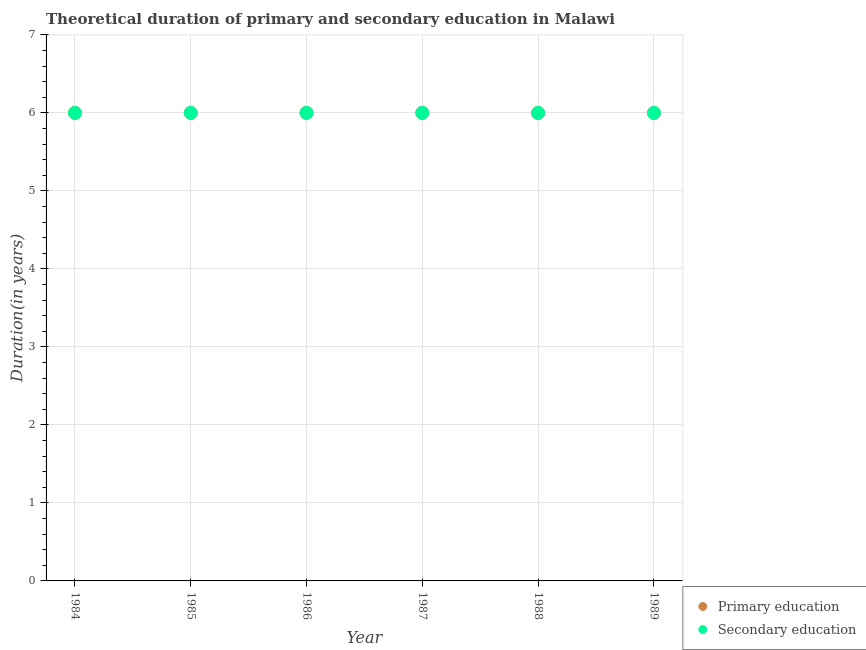Is the number of dotlines equal to the number of legend labels?
Offer a terse response. Yes. Across all years, what is the minimum duration of primary education?
Your answer should be compact. 6. In which year was the duration of primary education maximum?
Give a very brief answer. 1984. What is the total duration of primary education in the graph?
Offer a very short reply. 36. What is the difference between the duration of primary education in 1984 and that in 1988?
Ensure brevity in your answer.  0. What is the difference between the duration of primary education in 1989 and the duration of secondary education in 1988?
Give a very brief answer. 0. In the year 1988, what is the difference between the duration of secondary education and duration of primary education?
Give a very brief answer. 0. In how many years, is the duration of secondary education greater than 5.2 years?
Offer a very short reply. 6. Is the duration of secondary education in 1986 less than that in 1989?
Offer a very short reply. No. What is the difference between the highest and the second highest duration of secondary education?
Offer a very short reply. 0. In how many years, is the duration of primary education greater than the average duration of primary education taken over all years?
Your response must be concise. 0. Is the duration of primary education strictly greater than the duration of secondary education over the years?
Your answer should be compact. No. How many dotlines are there?
Keep it short and to the point. 2. How many years are there in the graph?
Keep it short and to the point. 6. What is the difference between two consecutive major ticks on the Y-axis?
Your answer should be very brief. 1. Where does the legend appear in the graph?
Offer a terse response. Bottom right. How many legend labels are there?
Give a very brief answer. 2. What is the title of the graph?
Give a very brief answer. Theoretical duration of primary and secondary education in Malawi. Does "Central government" appear as one of the legend labels in the graph?
Provide a succinct answer. No. What is the label or title of the Y-axis?
Ensure brevity in your answer.  Duration(in years). What is the Duration(in years) of Primary education in 1984?
Your answer should be very brief. 6. What is the Duration(in years) in Secondary education in 1984?
Your response must be concise. 6. What is the Duration(in years) in Primary education in 1989?
Your answer should be very brief. 6. Across all years, what is the maximum Duration(in years) of Primary education?
Provide a succinct answer. 6. Across all years, what is the minimum Duration(in years) in Primary education?
Give a very brief answer. 6. Across all years, what is the minimum Duration(in years) in Secondary education?
Your answer should be compact. 6. What is the total Duration(in years) in Primary education in the graph?
Your answer should be very brief. 36. What is the difference between the Duration(in years) of Primary education in 1984 and that in 1986?
Keep it short and to the point. 0. What is the difference between the Duration(in years) in Secondary education in 1984 and that in 1987?
Your answer should be compact. 0. What is the difference between the Duration(in years) in Primary education in 1984 and that in 1988?
Your response must be concise. 0. What is the difference between the Duration(in years) of Secondary education in 1984 and that in 1988?
Keep it short and to the point. 0. What is the difference between the Duration(in years) in Secondary education in 1984 and that in 1989?
Your answer should be compact. 0. What is the difference between the Duration(in years) of Secondary education in 1985 and that in 1986?
Provide a succinct answer. 0. What is the difference between the Duration(in years) in Primary education in 1985 and that in 1987?
Your response must be concise. 0. What is the difference between the Duration(in years) of Secondary education in 1985 and that in 1987?
Your answer should be very brief. 0. What is the difference between the Duration(in years) of Primary education in 1985 and that in 1988?
Provide a succinct answer. 0. What is the difference between the Duration(in years) of Secondary education in 1985 and that in 1988?
Offer a very short reply. 0. What is the difference between the Duration(in years) in Secondary education in 1985 and that in 1989?
Provide a succinct answer. 0. What is the difference between the Duration(in years) of Secondary education in 1986 and that in 1988?
Provide a short and direct response. 0. What is the difference between the Duration(in years) in Primary education in 1986 and that in 1989?
Offer a very short reply. 0. What is the difference between the Duration(in years) in Secondary education in 1986 and that in 1989?
Ensure brevity in your answer.  0. What is the difference between the Duration(in years) of Primary education in 1987 and that in 1988?
Give a very brief answer. 0. What is the difference between the Duration(in years) of Primary education in 1987 and that in 1989?
Offer a terse response. 0. What is the difference between the Duration(in years) of Secondary education in 1988 and that in 1989?
Provide a succinct answer. 0. What is the difference between the Duration(in years) in Primary education in 1984 and the Duration(in years) in Secondary education in 1985?
Keep it short and to the point. 0. What is the difference between the Duration(in years) of Primary education in 1984 and the Duration(in years) of Secondary education in 1986?
Offer a terse response. 0. What is the difference between the Duration(in years) of Primary education in 1984 and the Duration(in years) of Secondary education in 1988?
Make the answer very short. 0. What is the difference between the Duration(in years) of Primary education in 1985 and the Duration(in years) of Secondary education in 1988?
Keep it short and to the point. 0. What is the difference between the Duration(in years) of Primary education in 1985 and the Duration(in years) of Secondary education in 1989?
Your answer should be very brief. 0. What is the difference between the Duration(in years) of Primary education in 1987 and the Duration(in years) of Secondary education in 1989?
Keep it short and to the point. 0. What is the difference between the Duration(in years) in Primary education in 1988 and the Duration(in years) in Secondary education in 1989?
Offer a very short reply. 0. What is the average Duration(in years) of Secondary education per year?
Provide a short and direct response. 6. In the year 1984, what is the difference between the Duration(in years) in Primary education and Duration(in years) in Secondary education?
Make the answer very short. 0. In the year 1985, what is the difference between the Duration(in years) in Primary education and Duration(in years) in Secondary education?
Provide a succinct answer. 0. In the year 1987, what is the difference between the Duration(in years) of Primary education and Duration(in years) of Secondary education?
Offer a very short reply. 0. In the year 1989, what is the difference between the Duration(in years) in Primary education and Duration(in years) in Secondary education?
Offer a terse response. 0. What is the ratio of the Duration(in years) in Secondary education in 1984 to that in 1985?
Provide a short and direct response. 1. What is the ratio of the Duration(in years) in Primary education in 1984 to that in 1987?
Give a very brief answer. 1. What is the ratio of the Duration(in years) in Secondary education in 1984 to that in 1987?
Provide a short and direct response. 1. What is the ratio of the Duration(in years) of Secondary education in 1984 to that in 1988?
Your response must be concise. 1. What is the ratio of the Duration(in years) in Primary education in 1985 to that in 1986?
Your response must be concise. 1. What is the ratio of the Duration(in years) in Secondary education in 1985 to that in 1986?
Give a very brief answer. 1. What is the ratio of the Duration(in years) in Secondary education in 1985 to that in 1987?
Your answer should be very brief. 1. What is the ratio of the Duration(in years) in Primary education in 1986 to that in 1987?
Provide a short and direct response. 1. What is the ratio of the Duration(in years) of Primary education in 1986 to that in 1988?
Your answer should be compact. 1. What is the ratio of the Duration(in years) in Secondary education in 1986 to that in 1988?
Provide a short and direct response. 1. What is the ratio of the Duration(in years) in Secondary education in 1986 to that in 1989?
Offer a terse response. 1. What is the ratio of the Duration(in years) of Primary education in 1987 to that in 1988?
Make the answer very short. 1. What is the ratio of the Duration(in years) of Secondary education in 1987 to that in 1988?
Your response must be concise. 1. What is the ratio of the Duration(in years) in Primary education in 1987 to that in 1989?
Offer a terse response. 1. What is the ratio of the Duration(in years) of Secondary education in 1988 to that in 1989?
Give a very brief answer. 1. What is the difference between the highest and the second highest Duration(in years) in Primary education?
Make the answer very short. 0. What is the difference between the highest and the second highest Duration(in years) in Secondary education?
Your response must be concise. 0. 